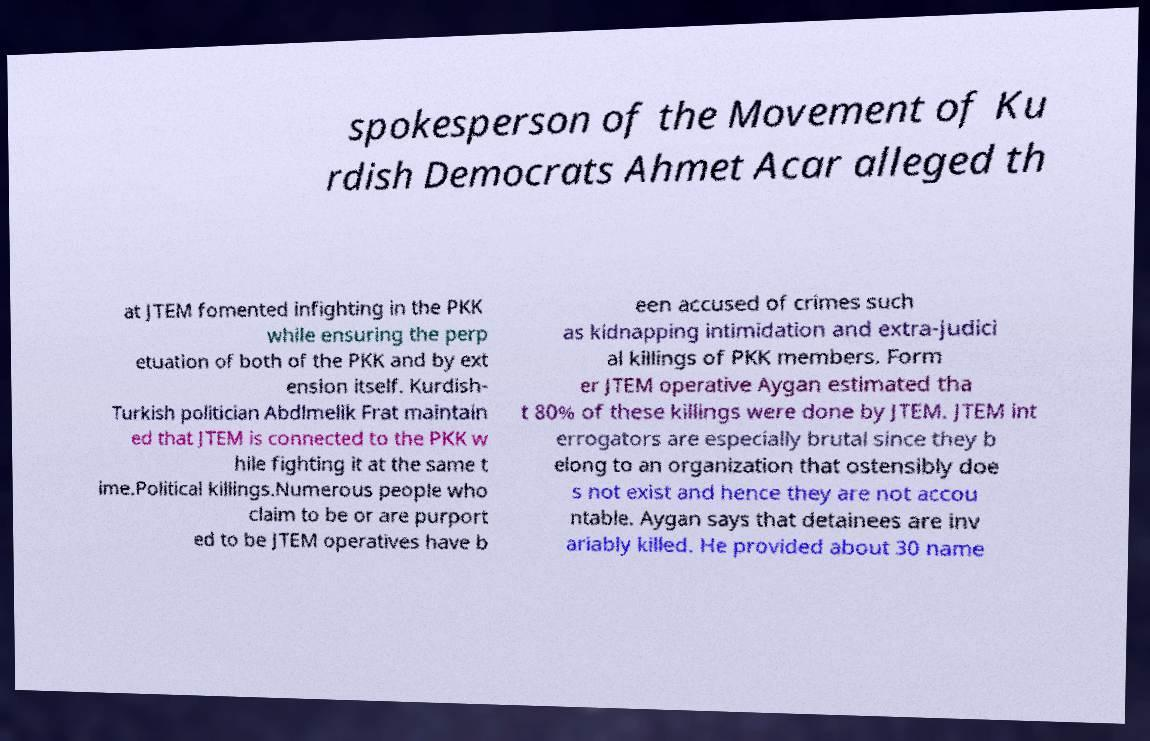Can you accurately transcribe the text from the provided image for me? spokesperson of the Movement of Ku rdish Democrats Ahmet Acar alleged th at JTEM fomented infighting in the PKK while ensuring the perp etuation of both of the PKK and by ext ension itself. Kurdish- Turkish politician Abdlmelik Frat maintain ed that JTEM is connected to the PKK w hile fighting it at the same t ime.Political killings.Numerous people who claim to be or are purport ed to be JTEM operatives have b een accused of crimes such as kidnapping intimidation and extra-judici al killings of PKK members. Form er JTEM operative Aygan estimated tha t 80% of these killings were done by JTEM. JTEM int errogators are especially brutal since they b elong to an organization that ostensibly doe s not exist and hence they are not accou ntable. Aygan says that detainees are inv ariably killed. He provided about 30 name 